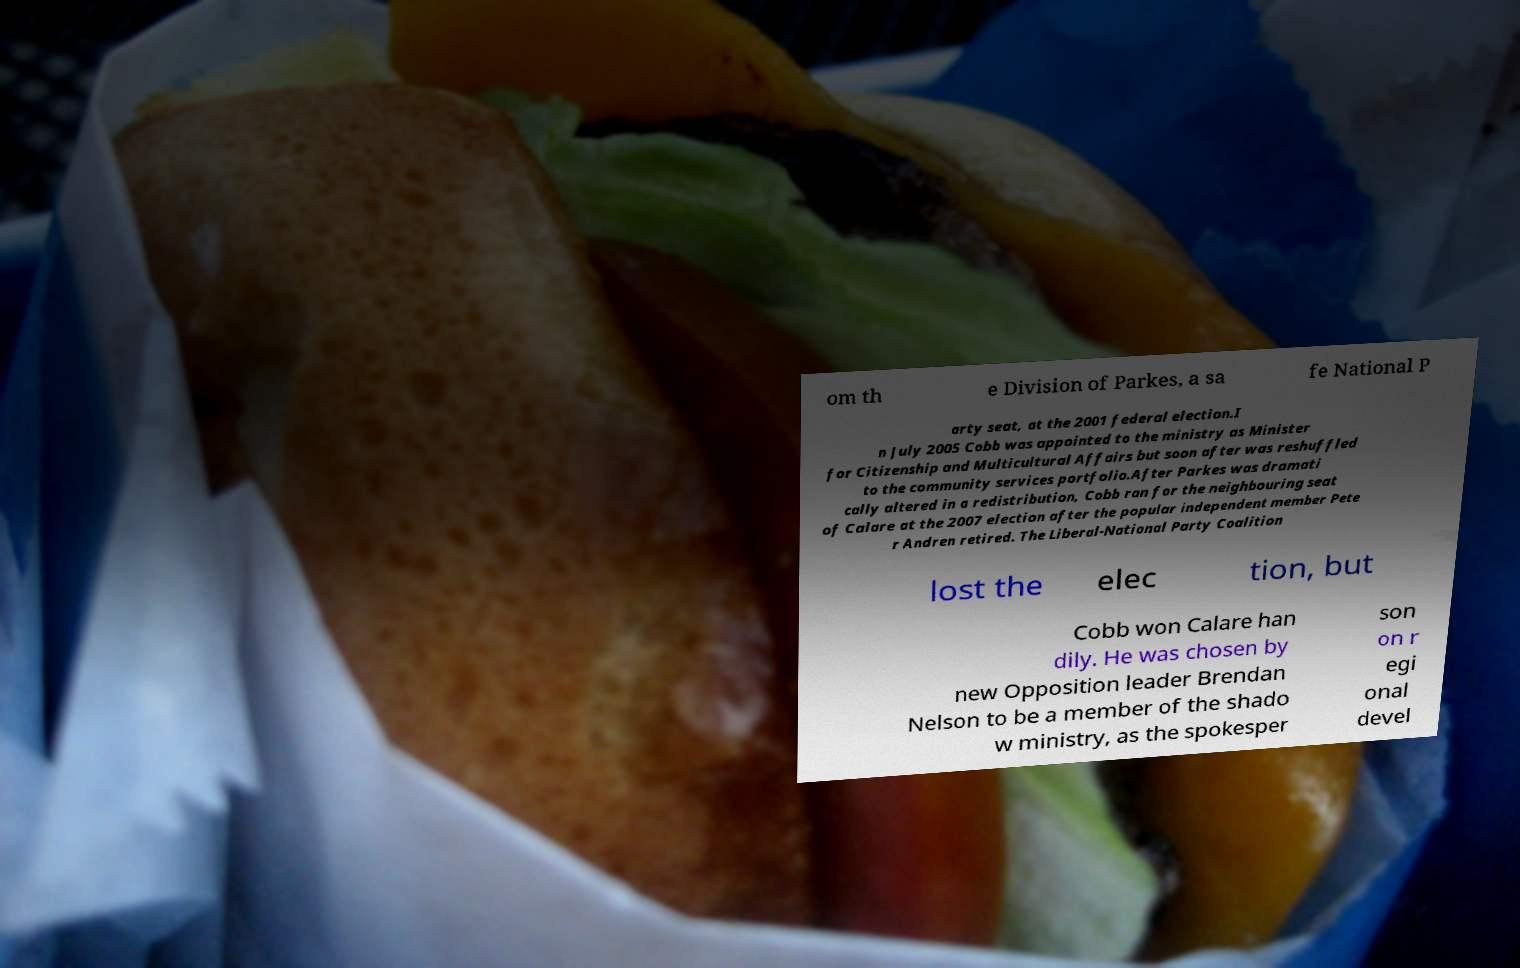Can you read and provide the text displayed in the image?This photo seems to have some interesting text. Can you extract and type it out for me? om th e Division of Parkes, a sa fe National P arty seat, at the 2001 federal election.I n July 2005 Cobb was appointed to the ministry as Minister for Citizenship and Multicultural Affairs but soon after was reshuffled to the community services portfolio.After Parkes was dramati cally altered in a redistribution, Cobb ran for the neighbouring seat of Calare at the 2007 election after the popular independent member Pete r Andren retired. The Liberal-National Party Coalition lost the elec tion, but Cobb won Calare han dily. He was chosen by new Opposition leader Brendan Nelson to be a member of the shado w ministry, as the spokesper son on r egi onal devel 